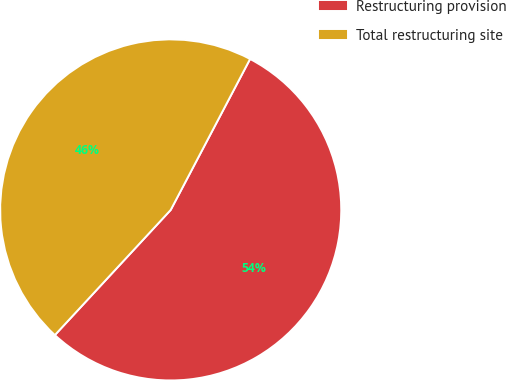Convert chart. <chart><loc_0><loc_0><loc_500><loc_500><pie_chart><fcel>Restructuring provision<fcel>Total restructuring site<nl><fcel>54.18%<fcel>45.82%<nl></chart> 